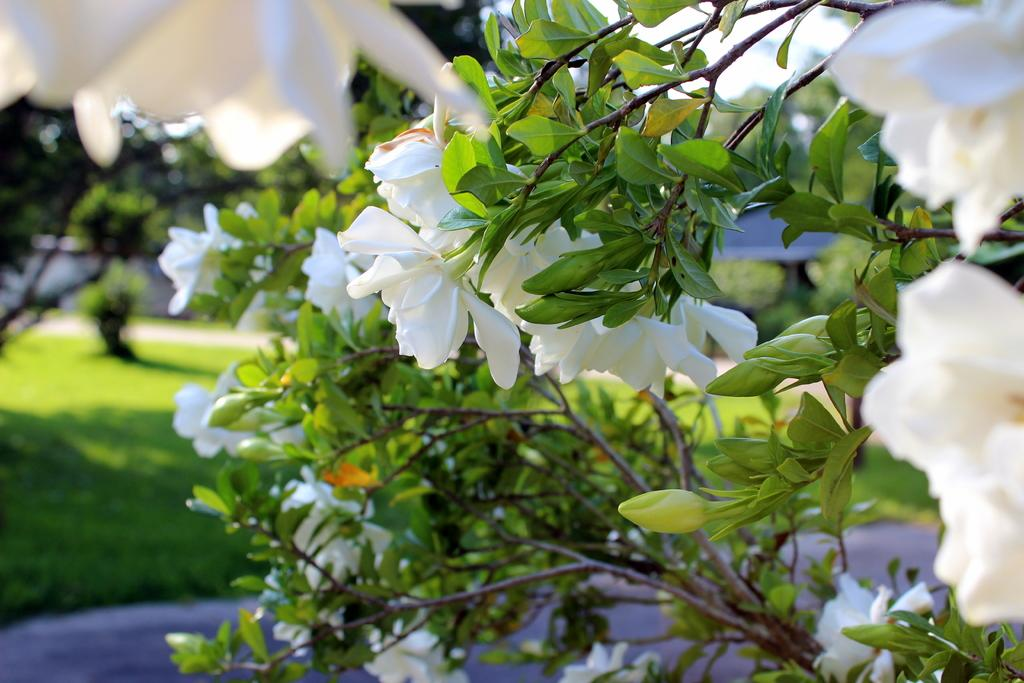What is located in the foreground of the picture? There are plants, leaves, and stems visible in the foreground of the picture. What can be seen in the background of the image? The background of the image is blurred, but there is greenery and the sky visible. How would you describe the plants in the foreground? The plants have leaves and stems visible. What type of boot is being worn by the creator of the plants in the image? There is no creator of the plants visible in the image, and no boots are present. 